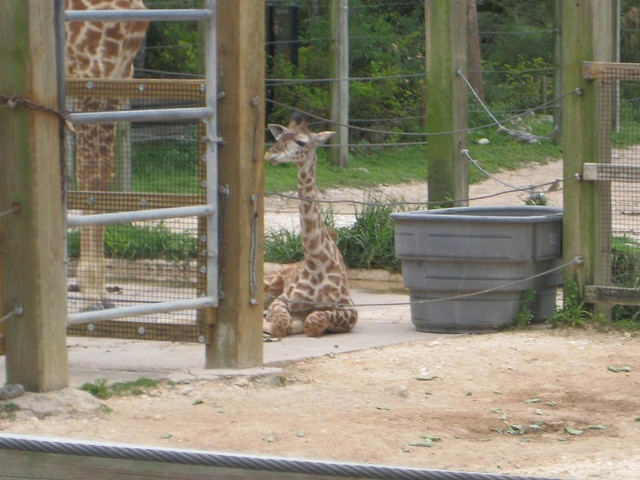Describe the objects in this image and their specific colors. I can see giraffe in gray and darkgray tones and giraffe in gray and darkgray tones in this image. 